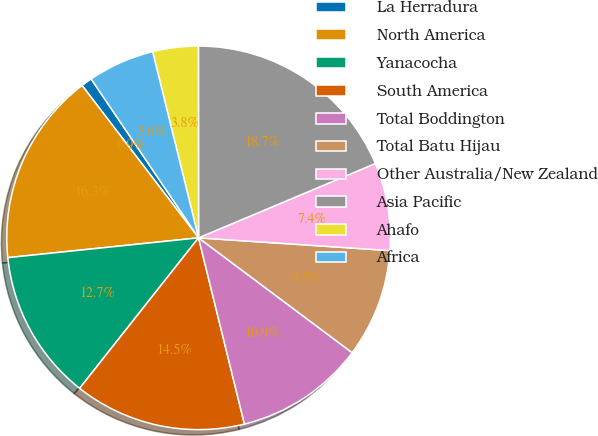Convert chart. <chart><loc_0><loc_0><loc_500><loc_500><pie_chart><fcel>La Herradura<fcel>North America<fcel>Yanacocha<fcel>South America<fcel>Total Boddington<fcel>Total Batu Hijau<fcel>Other Australia/New Zealand<fcel>Asia Pacific<fcel>Ahafo<fcel>Africa<nl><fcel>0.93%<fcel>16.26%<fcel>12.71%<fcel>14.49%<fcel>10.94%<fcel>9.16%<fcel>7.39%<fcel>18.68%<fcel>3.84%<fcel>5.61%<nl></chart> 